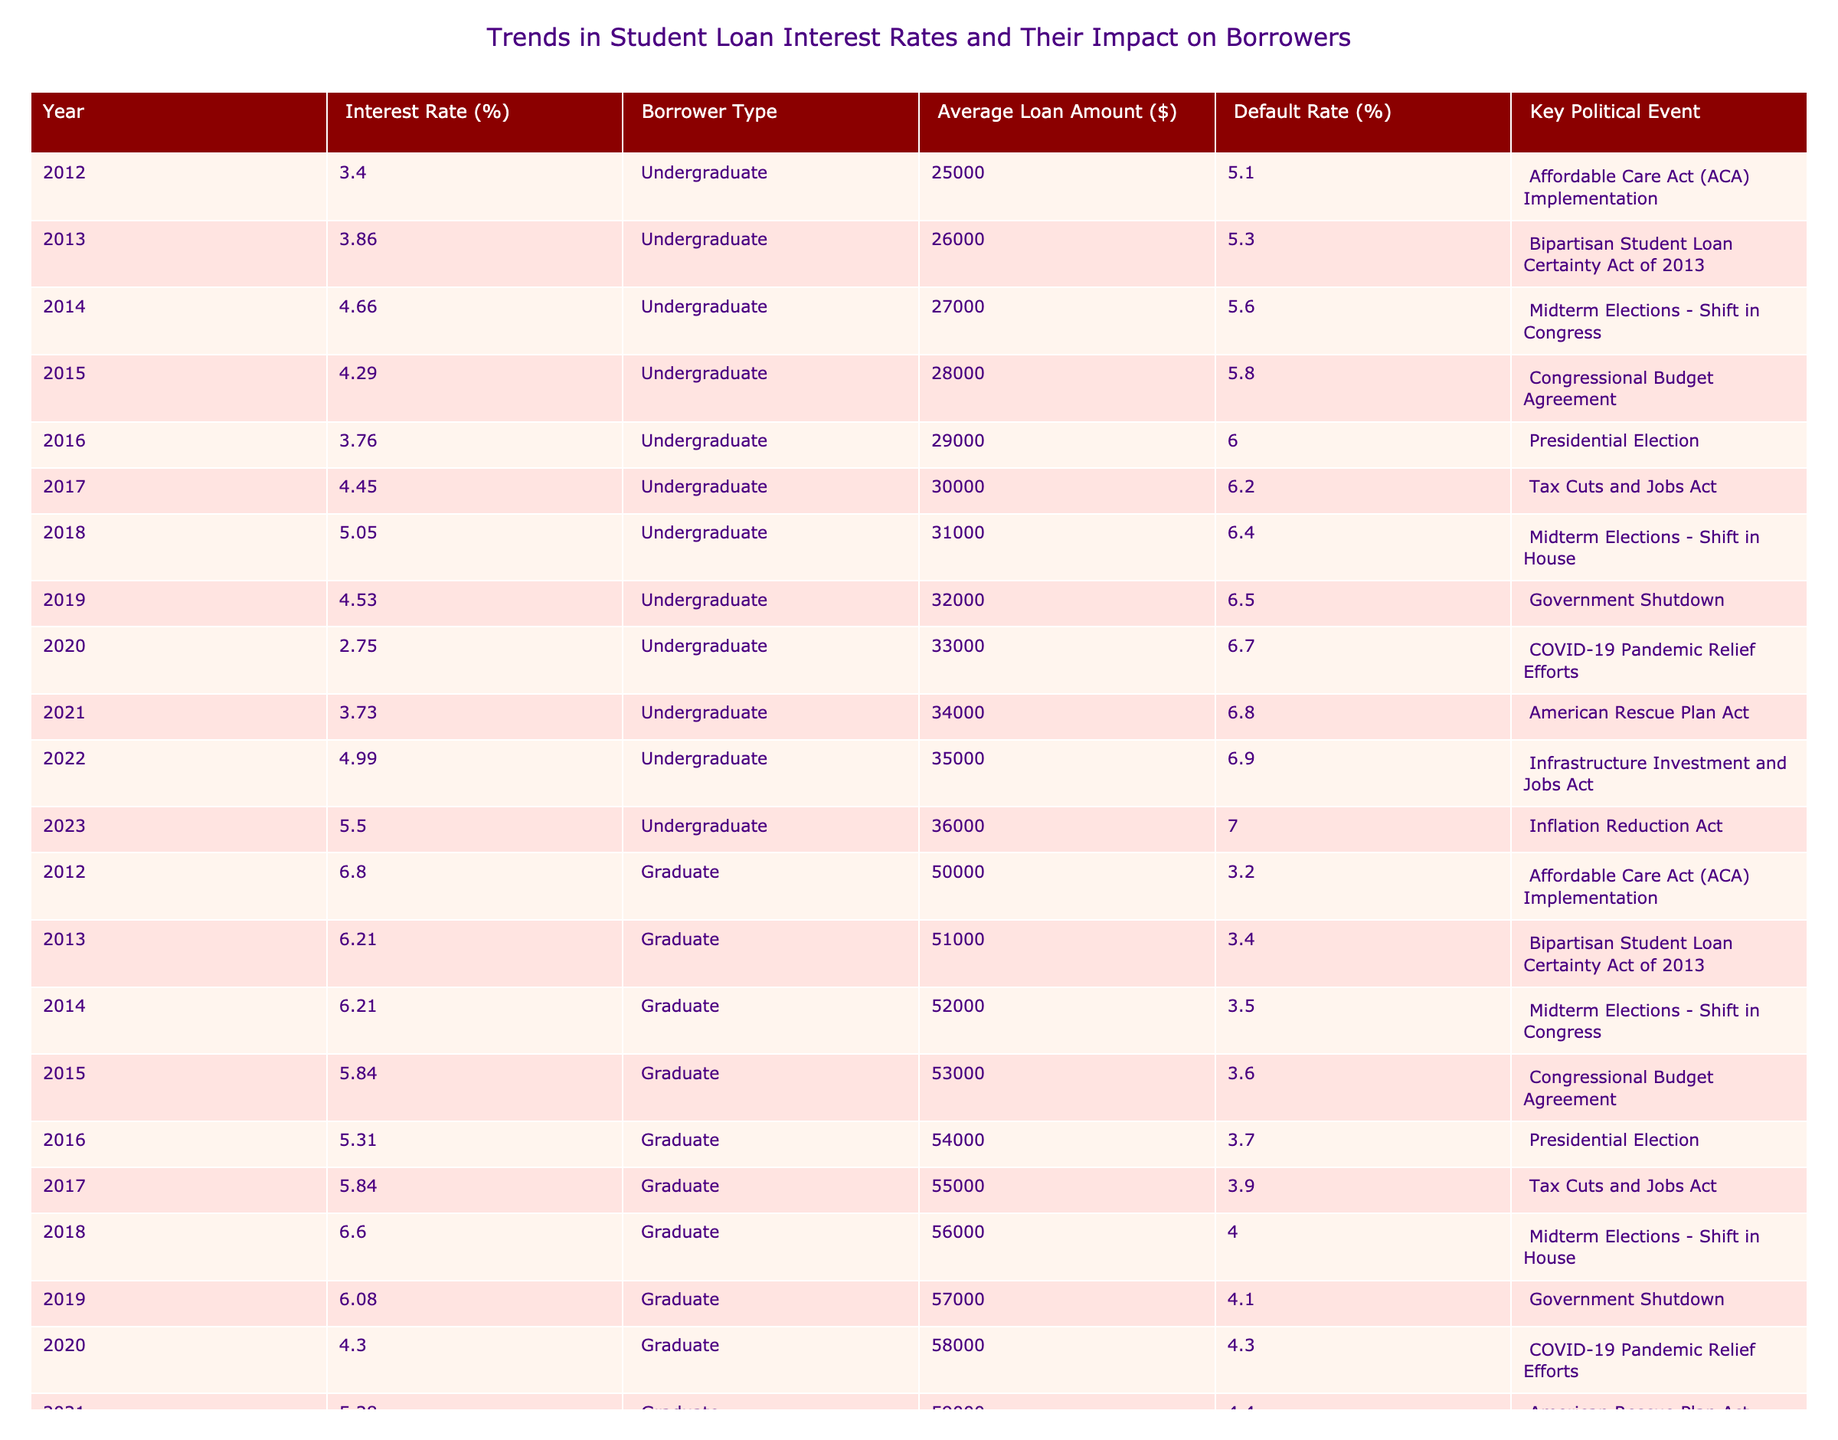What was the interest rate for undergraduate loans in 2020? In 2020, the table shows the interest rate for undergraduate loans was 2.75%. This value can be directly retrieved from the corresponding row for that year.
Answer: 2.75% Which year had the highest average loan amount for graduate borrowers? The table indicates that the highest average loan amount for graduate borrowers was $61,000 in 2023. This is determined by scanning through the average loan amounts in the graduate row and identifying the maximum value.
Answer: 61000 Did the default rate for undergraduate loans increase consistently from 2012 to 2023? The default rates for undergraduate loans increased from 5.1% in 2012 to 7.0% in 2023. However, a closer look shows that while there is a general upward trend, the rate did not consistently increase every year; for instance, it dropped from 4.66% in 2014 to 4.29% in 2015. Thus, the statement is false.
Answer: No What was the average interest rate for graduate loans in the years 2015 and 2016? The interest rates for graduate loans in 2015 and 2016 were 5.84% and 5.31%, respectively. To find the average, add these two values (5.84 + 5.31 = 11.15) and divide by 2, resulting in an average of 5.575%.
Answer: 5.575 In which year did the default rate for graduate loans fall below 4%? The default rate for graduate loans fell below 4% in the year 2020, where it is stated as 4.3%. This can be identified by examining the default rates across all the years for graduate borrowers and identifying the year with rates less than 4%.
Answer: 2020 How did the interest rates for undergraduate loans compare between 2019 and 2021? In 2019, the interest rate for undergraduate loans was 4.53%, while in 2021 it rose to 3.73%. The comparison indicates that the interest rate in 2021 was lower than in 2019. The difference shows a decrease of 0.80%.
Answer: 4.53% > 3.73% What was the key political event in the same year as the highest interest rate for undergraduate loans? The highest interest rate for undergraduate loans was 5.50%, which occurred in 2023. The key political event for that year was the Inflation Reduction Act. This was found by cross-referencing the row with the highest interest rate and checking the political event column for the same year.
Answer: Inflation Reduction Act What trend can we observe in the graduate borrowers' average loan amounts from 2012 to 2023? The average loan amounts for graduate borrowers increased steadily from $50,000 in 2012 to $61,000 in 2023. This is determined by reviewing the average loan amounts listed for each year and noticing the overall upward trend with no decreases, indicating consistent growth.
Answer: Increasing 